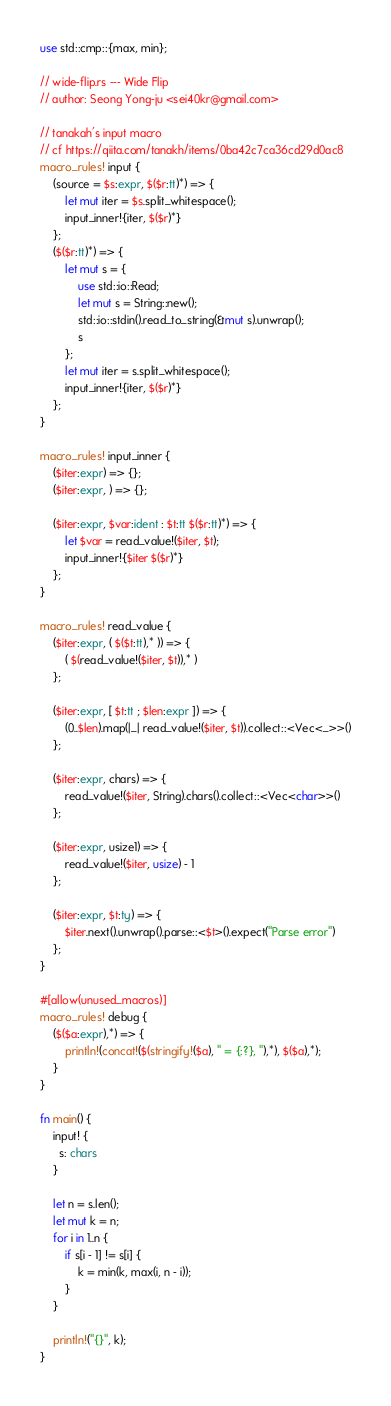<code> <loc_0><loc_0><loc_500><loc_500><_Rust_>use std::cmp::{max, min};

// wide-flip.rs --- Wide Flip
// author: Seong Yong-ju <sei40kr@gmail.com>

// tanakah's input macro
// cf https://qiita.com/tanakh/items/0ba42c7ca36cd29d0ac8
macro_rules! input {
    (source = $s:expr, $($r:tt)*) => {
        let mut iter = $s.split_whitespace();
        input_inner!{iter, $($r)*}
    };
    ($($r:tt)*) => {
        let mut s = {
            use std::io::Read;
            let mut s = String::new();
            std::io::stdin().read_to_string(&mut s).unwrap();
            s
        };
        let mut iter = s.split_whitespace();
        input_inner!{iter, $($r)*}
    };
}

macro_rules! input_inner {
    ($iter:expr) => {};
    ($iter:expr, ) => {};

    ($iter:expr, $var:ident : $t:tt $($r:tt)*) => {
        let $var = read_value!($iter, $t);
        input_inner!{$iter $($r)*}
    };
}

macro_rules! read_value {
    ($iter:expr, ( $($t:tt),* )) => {
        ( $(read_value!($iter, $t)),* )
    };

    ($iter:expr, [ $t:tt ; $len:expr ]) => {
        (0..$len).map(|_| read_value!($iter, $t)).collect::<Vec<_>>()
    };

    ($iter:expr, chars) => {
        read_value!($iter, String).chars().collect::<Vec<char>>()
    };

    ($iter:expr, usize1) => {
        read_value!($iter, usize) - 1
    };

    ($iter:expr, $t:ty) => {
        $iter.next().unwrap().parse::<$t>().expect("Parse error")
    };
}

#[allow(unused_macros)]
macro_rules! debug {
    ($($a:expr),*) => {
        println!(concat!($(stringify!($a), " = {:?}, "),*), $($a),*);
    }
}

fn main() {
    input! {
      s: chars
    }

    let n = s.len();
    let mut k = n;
    for i in 1..n {
        if s[i - 1] != s[i] {
            k = min(k, max(i, n - i));
        }
    }

    println!("{}", k);
}
</code> 